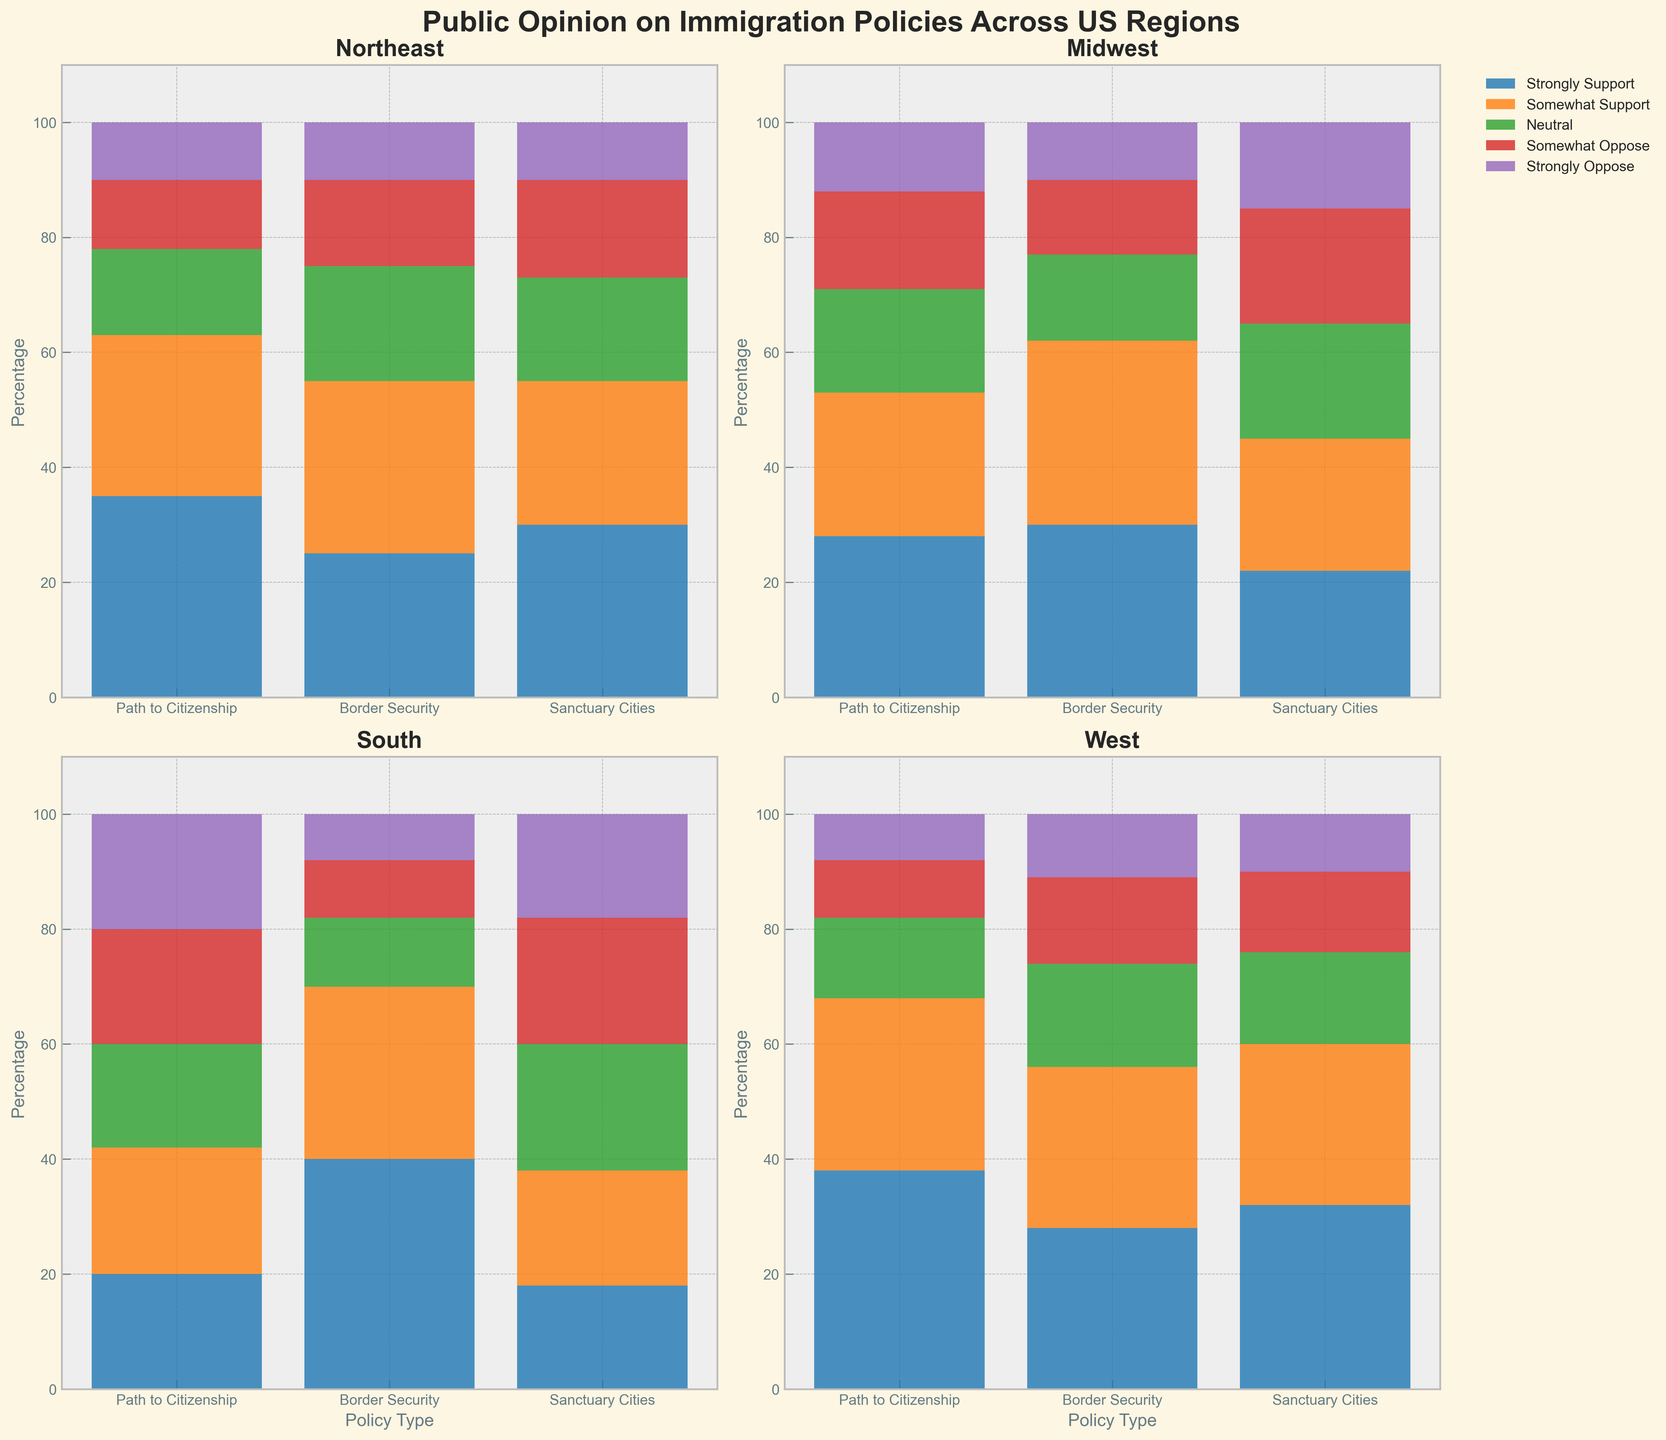What is the title of the figure? The title of the figure is displayed at the top and bolded. It is 'Public Opinion on Immigration Policies Across US Regions'.
Answer: Public Opinion on Immigration Policies Across US Regions Which region shows the highest percentage of 'Strongly Support' for 'Border Security'? For each region, the percentage of 'Strongly Support' can be checked in the corresponding subplot. The South region has the highest percentage at 40%.
Answer: South Which region has the least support ('Strongly Support' + 'Somewhat Support') for 'Path to Citizenship'? We need to sum the 'Strongly Support' and 'Somewhat Support' percentages for 'Path to Citizenship' in each region. The sums are: Northeast (63), Midwest (53), South (42), and West (68). The South has the least support.
Answer: South What is the combined percentage of 'Neutral' responses for 'Sanctuary Cities' across all regions? We need to add the 'Neutral' percentages from each region for 'Sanctuary Cities': Northeast (18) + Midwest (20) + South (22) + West (16). This gives us a total of 76.
Answer: 76 In the Midwest, which policy type has the highest percentage of 'Somewhat Oppose'? Looking at the Midwest subplot, we need to compare the 'Somewhat Oppose' percentages for each policy type. They are: Path to Citizenship (17), Border Security (13), and Sanctuary Cities (20). Sanctuary Cities has the highest percentage.
Answer: Sanctuary Cities Which region’s ‘Border Security’ policy has the most uniformly distributed opinion (least variation among categories)? We must compare the range of values within the categories of 'Border Security' in each region; lower range indicates more uniform distribution. The South has the most uniform distribution with values 40, 30, 12, 10, and 8.
Answer: South Do 'Strongly Oppose' percentages for 'Sanctuary Cities' vary more across regions compared to 'Somewhat Support' percentages for 'Path to Citizenship'? Calculate the range for 'Strongly Oppose' percentages for 'Sanctuary Cities' (18-10=8) and 'Somewhat Support' for 'Path to Citizenship' (30-22=8). Equal, so no variation difference.
Answer: No How many regions have 'Strongly Support' percentages greater than 30% for at least one policy type? Check each region's 'Strongly Support' percentages for all policy types and count regions with any value over 30%. Northeast (2 policies), South (1 policy), and West (2 policies) have at least one such policy. Midwest has none.
Answer: 3 regions For the West, what is the total percentage of people who 'Oppose' (both 'Somewhat' and 'Strongly') to 'Path to Citizenship'? In the West subplot, sum the 'Somewhat Oppose' (10) and 'Strongly Oppose' (8) for 'Path to Citizenship'. The total is 10 + 8 = 18.
Answer: 18 Which region displays the highest ‘Neutral’ opinion on any policy type, and which policy is it? Identify the highest 'Neutral' percentage for any policy in each region and determine which is highest. West (14), Northeast (20), Midwest (20), South (22). The highest is the South for 'Sanctuary Cities' at 22%.
Answer: South, Sanctuary Cities 